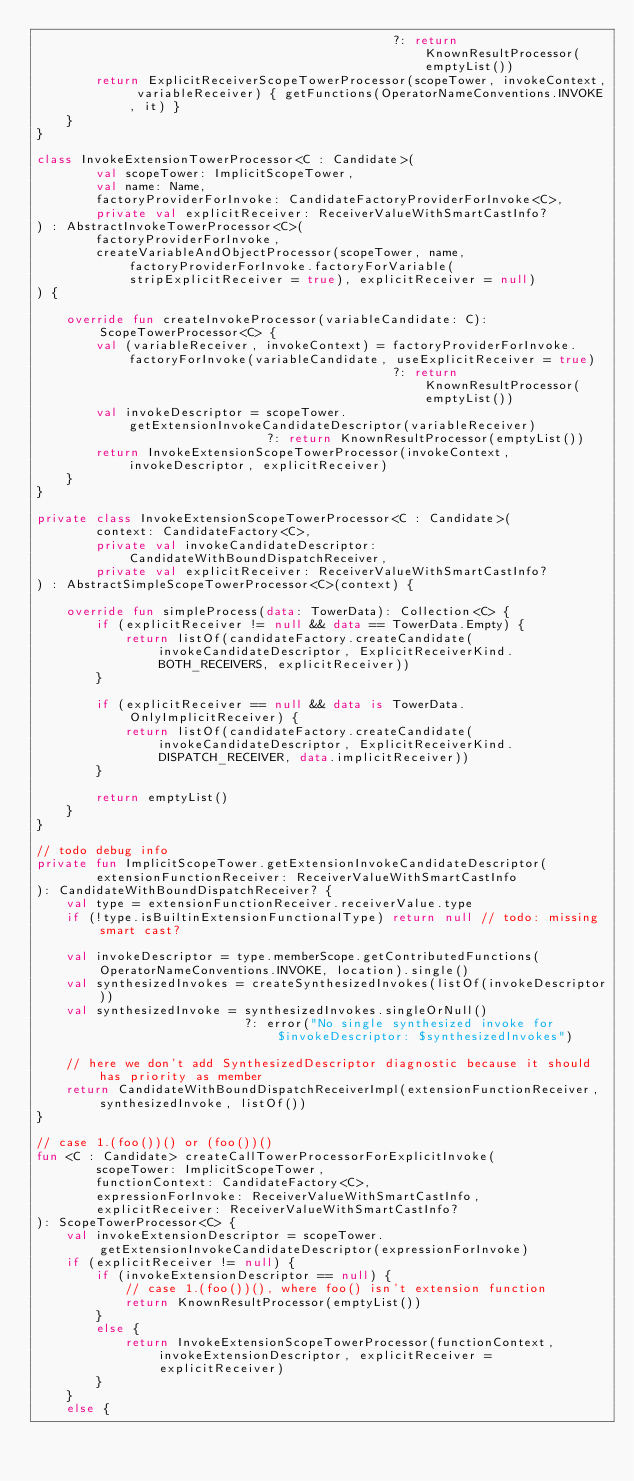Convert code to text. <code><loc_0><loc_0><loc_500><loc_500><_Kotlin_>                                                ?: return KnownResultProcessor(emptyList())
        return ExplicitReceiverScopeTowerProcessor(scopeTower, invokeContext, variableReceiver) { getFunctions(OperatorNameConventions.INVOKE, it) }
    }
}

class InvokeExtensionTowerProcessor<C : Candidate>(
        val scopeTower: ImplicitScopeTower,
        val name: Name,
        factoryProviderForInvoke: CandidateFactoryProviderForInvoke<C>,
        private val explicitReceiver: ReceiverValueWithSmartCastInfo?
) : AbstractInvokeTowerProcessor<C>(
        factoryProviderForInvoke,
        createVariableAndObjectProcessor(scopeTower, name, factoryProviderForInvoke.factoryForVariable(stripExplicitReceiver = true), explicitReceiver = null)
) {

    override fun createInvokeProcessor(variableCandidate: C): ScopeTowerProcessor<C> {
        val (variableReceiver, invokeContext) = factoryProviderForInvoke.factoryForInvoke(variableCandidate, useExplicitReceiver = true)
                                                ?: return KnownResultProcessor(emptyList())
        val invokeDescriptor = scopeTower.getExtensionInvokeCandidateDescriptor(variableReceiver)
                               ?: return KnownResultProcessor(emptyList())
        return InvokeExtensionScopeTowerProcessor(invokeContext, invokeDescriptor, explicitReceiver)
    }
}

private class InvokeExtensionScopeTowerProcessor<C : Candidate>(
        context: CandidateFactory<C>,
        private val invokeCandidateDescriptor: CandidateWithBoundDispatchReceiver,
        private val explicitReceiver: ReceiverValueWithSmartCastInfo?
) : AbstractSimpleScopeTowerProcessor<C>(context) {

    override fun simpleProcess(data: TowerData): Collection<C> {
        if (explicitReceiver != null && data == TowerData.Empty) {
            return listOf(candidateFactory.createCandidate(invokeCandidateDescriptor, ExplicitReceiverKind.BOTH_RECEIVERS, explicitReceiver))
        }

        if (explicitReceiver == null && data is TowerData.OnlyImplicitReceiver) {
            return listOf(candidateFactory.createCandidate(invokeCandidateDescriptor, ExplicitReceiverKind.DISPATCH_RECEIVER, data.implicitReceiver))
        }

        return emptyList()
    }
}

// todo debug info
private fun ImplicitScopeTower.getExtensionInvokeCandidateDescriptor(
        extensionFunctionReceiver: ReceiverValueWithSmartCastInfo
): CandidateWithBoundDispatchReceiver? {
    val type = extensionFunctionReceiver.receiverValue.type
    if (!type.isBuiltinExtensionFunctionalType) return null // todo: missing smart cast?

    val invokeDescriptor = type.memberScope.getContributedFunctions(OperatorNameConventions.INVOKE, location).single()
    val synthesizedInvokes = createSynthesizedInvokes(listOf(invokeDescriptor))
    val synthesizedInvoke = synthesizedInvokes.singleOrNull()
                            ?: error("No single synthesized invoke for $invokeDescriptor: $synthesizedInvokes")

    // here we don't add SynthesizedDescriptor diagnostic because it should has priority as member
    return CandidateWithBoundDispatchReceiverImpl(extensionFunctionReceiver, synthesizedInvoke, listOf())
}

// case 1.(foo())() or (foo())()
fun <C : Candidate> createCallTowerProcessorForExplicitInvoke(
        scopeTower: ImplicitScopeTower,
        functionContext: CandidateFactory<C>,
        expressionForInvoke: ReceiverValueWithSmartCastInfo,
        explicitReceiver: ReceiverValueWithSmartCastInfo?
): ScopeTowerProcessor<C> {
    val invokeExtensionDescriptor = scopeTower.getExtensionInvokeCandidateDescriptor(expressionForInvoke)
    if (explicitReceiver != null) {
        if (invokeExtensionDescriptor == null) {
            // case 1.(foo())(), where foo() isn't extension function
            return KnownResultProcessor(emptyList())
        }
        else {
            return InvokeExtensionScopeTowerProcessor(functionContext, invokeExtensionDescriptor, explicitReceiver = explicitReceiver)
        }
    }
    else {</code> 